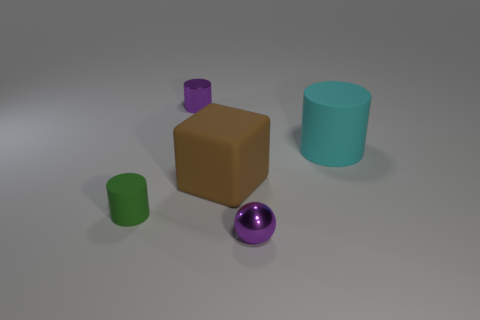Add 1 purple objects. How many objects exist? 6 Subtract all blocks. How many objects are left? 4 Add 3 large cyan cylinders. How many large cyan cylinders exist? 4 Subtract 1 purple cylinders. How many objects are left? 4 Subtract all big cubes. Subtract all purple things. How many objects are left? 2 Add 3 matte blocks. How many matte blocks are left? 4 